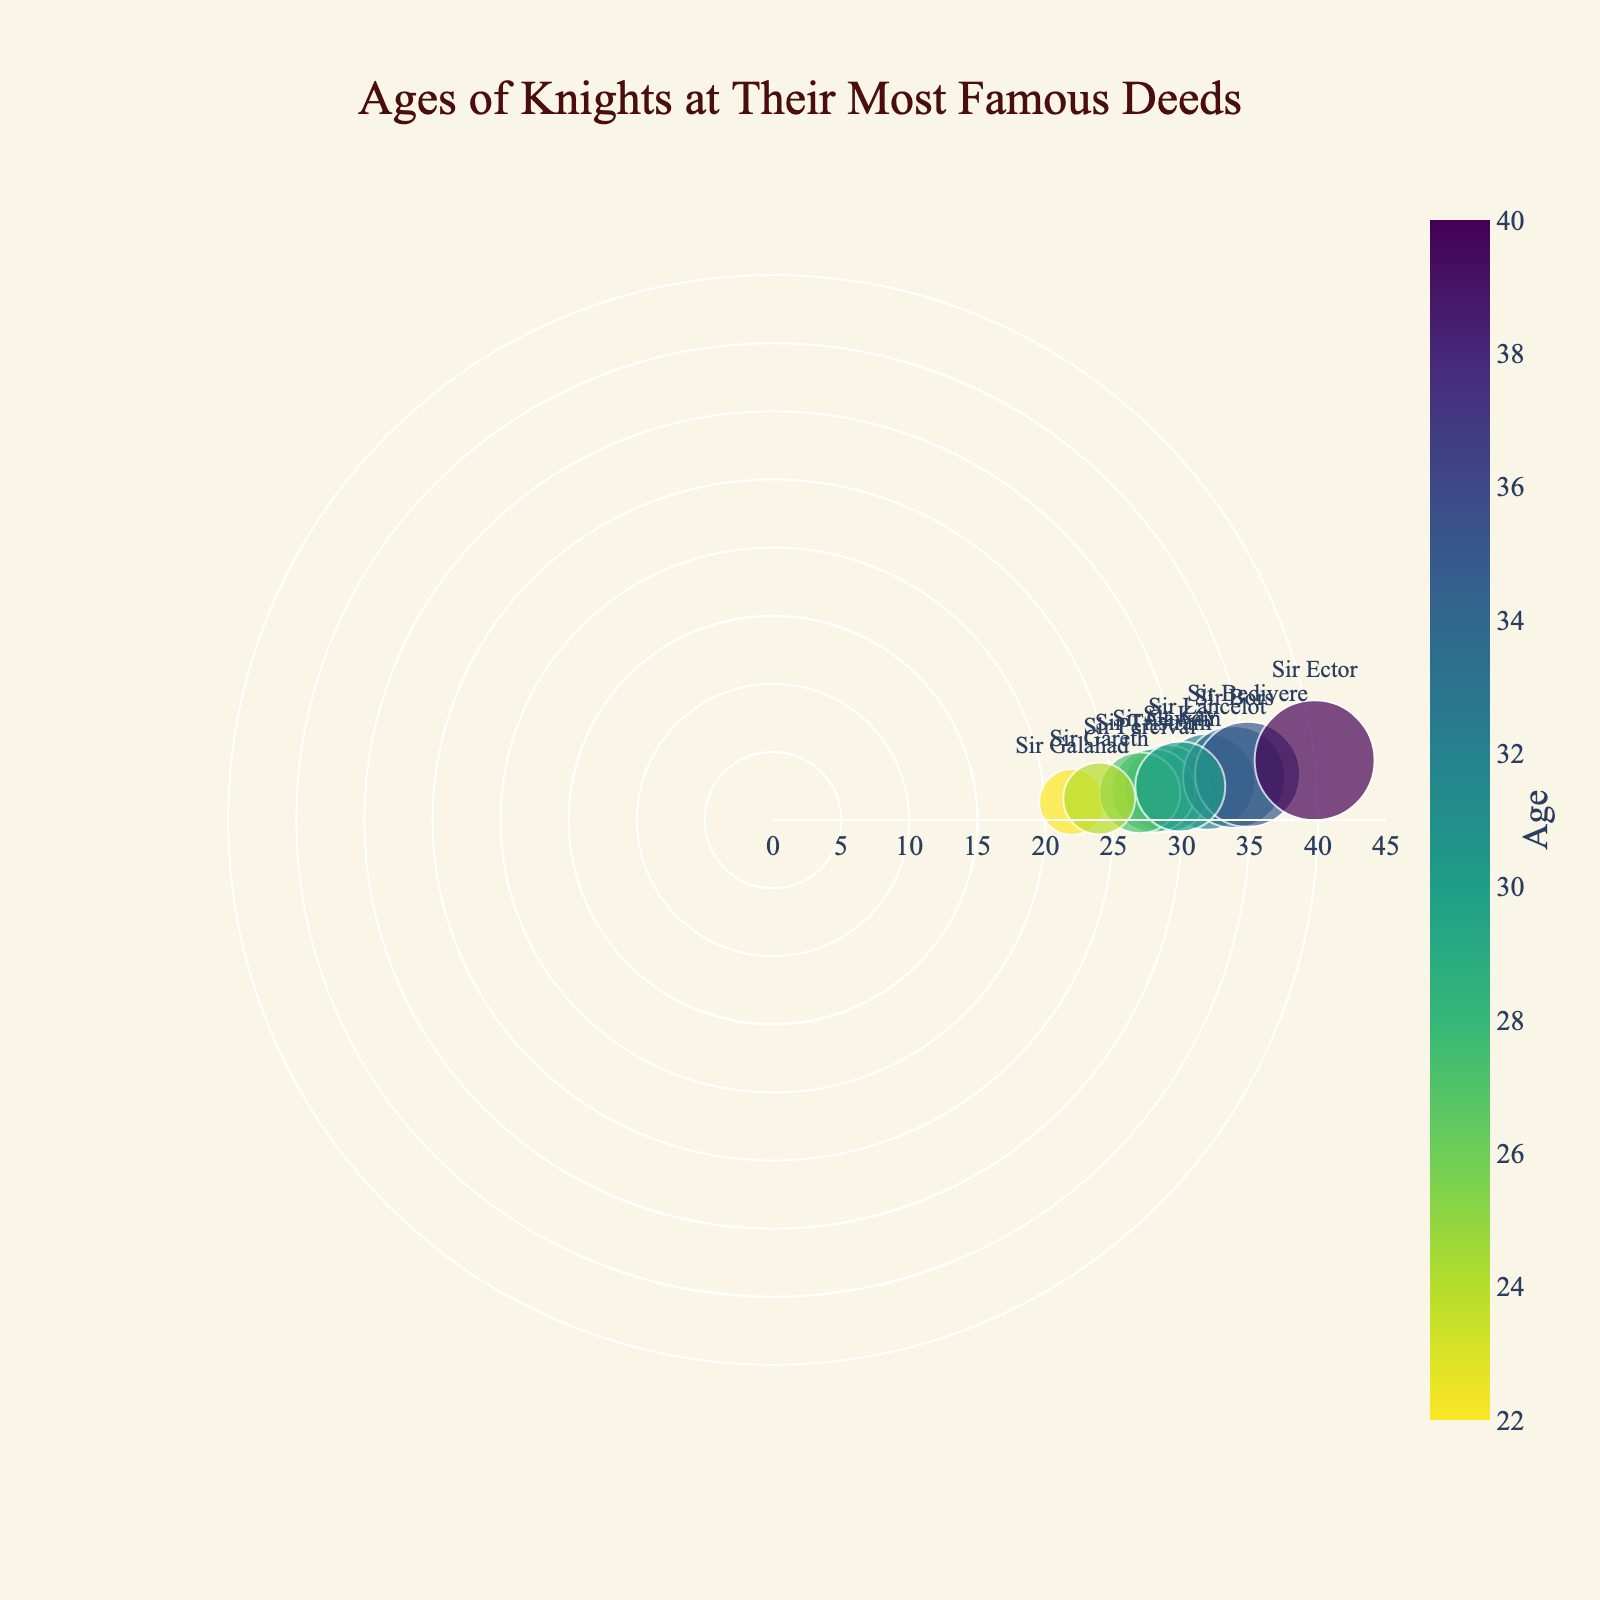What's the title of this figure? The text at the top center of the figure reads "Ages of Knights at Their Most Famous Deeds"
Answer: Ages of Knights at Their Most Famous Deeds How many knights are plotted in this figure? Count the number of unique data points (markers) on the plot. Each marker represents a knight. There are 10 points.
Answer: 10 Who is the oldest knight in this plot and what deed is he known for? Look for the knight with the marker furthest from the center, indicating the highest age. Sir Ector's marker is at age 40. Hovering over his marker shows his deed: "Adoption of King Arthur."
Answer: Sir Ector with Adoption of King Arthur Which two knights performed their famous deeds at the same age? Look for two markers that are the same distance from the center. Sir Tristram and Sir Percival both have markers at age 28. Hovering over their markers confirms their deeds: "Defeating King Marhaus" and "Finding the Holy Grail," respectively.
Answer: Sir Tristram and Sir Percival What is the average age of the knights at the time of their deeds? Add all the ages and divide by the total number of knights. Ages: (32 + 29 + 22 + 28 + 27 + 34 + 24 + 35 + 30 + 40) = 301. There are 10 knights, so the average age is 301/10 = 30.1
Answer: 30.1 Who was the knight youngest when performing their famous deed, and what deed was it? Identify the marker closest to the center, indicating the smallest age. Sir Galahad's marker is at age 22. Hovering over his marker reveals his deed: "Quest for the Holy Grail."
Answer: Sir Galahad with Quest for the Holy Grail What is the age range of the knights shown in the plot? The age range is determined by finding the difference between the oldest knight (age 40) and the youngest knight (age 22). So, the age range is 40 - 22 = 18.
Answer: 18 Which knight's marker on the plot has the largest size and what is his age? The size of the markers is proportional to the age of the knights. The largest marker is for the oldest knight, Sir Ector, who is 40 years old.
Answer: Sir Ector, 40 Compare the ages of Sir Kay and Sir Bedivere. Who is older and by how many years? From the plot, Sir Kay is marked at age 30 and Sir Bedivere at age 35. The difference in age is 35 - 30 = 5 years. Sir Bedivere is older by 5 years.
Answer: Sir Bedivere by 5 years 